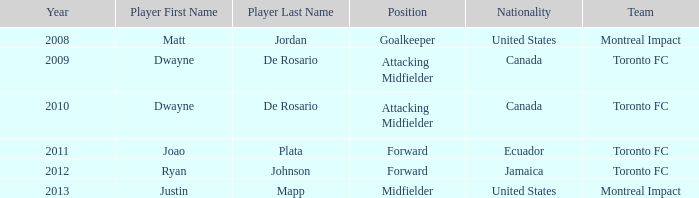Following 2009, which athlete with canadian citizenship emerged? Dwayne De Rosario Category:Articles with hCards. Could you parse the entire table as a dict? {'header': ['Year', 'Player First Name', 'Player Last Name', 'Position', 'Nationality', 'Team'], 'rows': [['2008', 'Matt', 'Jordan', 'Goalkeeper', 'United States', 'Montreal Impact'], ['2009', 'Dwayne', 'De Rosario', 'Attacking Midfielder', 'Canada', 'Toronto FC'], ['2010', 'Dwayne', 'De Rosario', 'Attacking Midfielder', 'Canada', 'Toronto FC'], ['2011', 'Joao', 'Plata', 'Forward', 'Ecuador', 'Toronto FC'], ['2012', 'Ryan', 'Johnson', 'Forward', 'Jamaica', 'Toronto FC'], ['2013', 'Justin', 'Mapp', 'Midfielder', 'United States', 'Montreal Impact']]} 